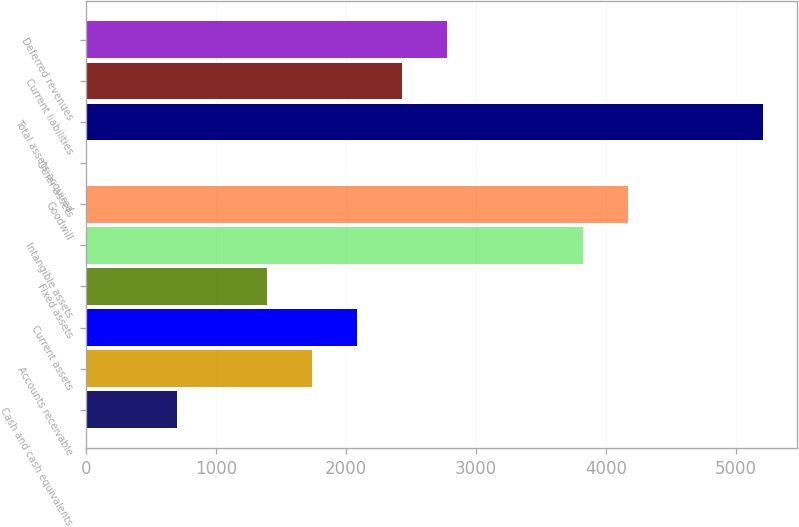<chart> <loc_0><loc_0><loc_500><loc_500><bar_chart><fcel>Cash and cash equivalents<fcel>Accounts receivable<fcel>Current assets<fcel>Fixed assets<fcel>Intangible assets<fcel>Goodwill<fcel>Other assets<fcel>Total assets acquired<fcel>Current liabilities<fcel>Deferred revenues<nl><fcel>700.16<fcel>1739.9<fcel>2086.48<fcel>1393.32<fcel>3819.38<fcel>4165.96<fcel>7<fcel>5205.7<fcel>2433.06<fcel>2779.64<nl></chart> 